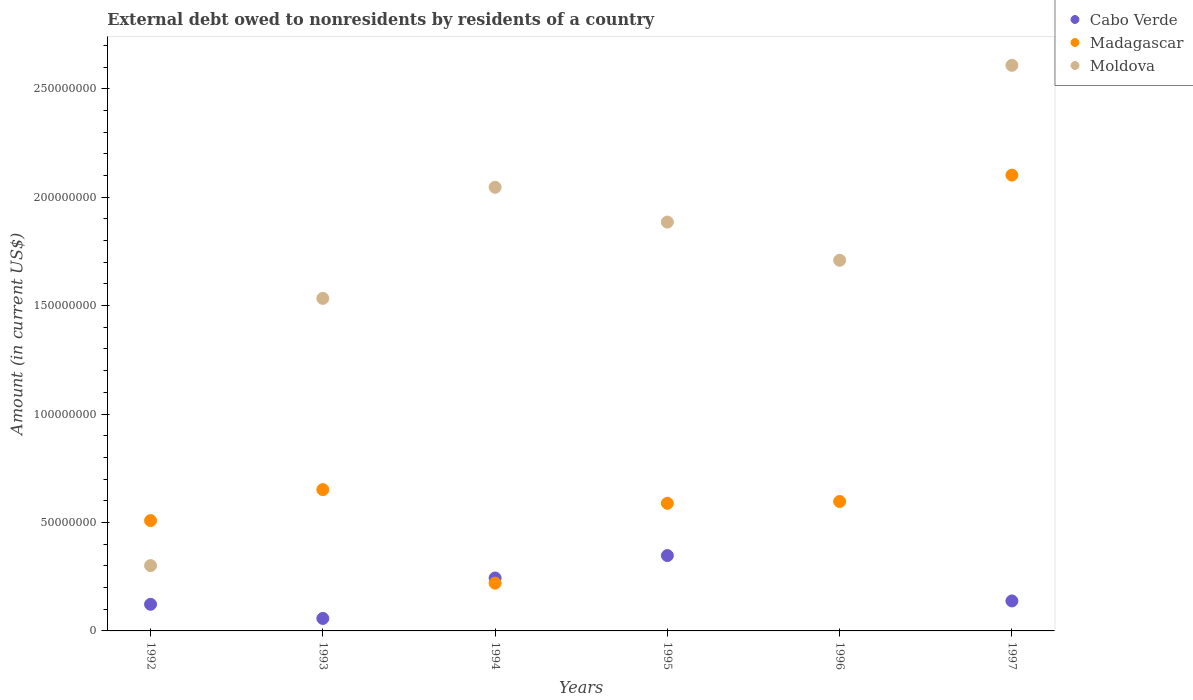How many different coloured dotlines are there?
Offer a terse response. 3. Is the number of dotlines equal to the number of legend labels?
Offer a terse response. No. What is the external debt owed by residents in Moldova in 1994?
Offer a terse response. 2.05e+08. Across all years, what is the maximum external debt owed by residents in Cabo Verde?
Your answer should be very brief. 3.47e+07. Across all years, what is the minimum external debt owed by residents in Madagascar?
Make the answer very short. 2.20e+07. In which year was the external debt owed by residents in Moldova maximum?
Your response must be concise. 1997. What is the total external debt owed by residents in Madagascar in the graph?
Make the answer very short. 4.67e+08. What is the difference between the external debt owed by residents in Madagascar in 1994 and that in 1997?
Ensure brevity in your answer.  -1.88e+08. What is the difference between the external debt owed by residents in Cabo Verde in 1992 and the external debt owed by residents in Madagascar in 1995?
Keep it short and to the point. -4.66e+07. What is the average external debt owed by residents in Madagascar per year?
Keep it short and to the point. 7.78e+07. In the year 1993, what is the difference between the external debt owed by residents in Moldova and external debt owed by residents in Madagascar?
Provide a short and direct response. 8.82e+07. What is the ratio of the external debt owed by residents in Moldova in 1994 to that in 1996?
Your answer should be very brief. 1.2. Is the difference between the external debt owed by residents in Moldova in 1993 and 1994 greater than the difference between the external debt owed by residents in Madagascar in 1993 and 1994?
Give a very brief answer. No. What is the difference between the highest and the second highest external debt owed by residents in Madagascar?
Make the answer very short. 1.45e+08. What is the difference between the highest and the lowest external debt owed by residents in Madagascar?
Your answer should be compact. 1.88e+08. In how many years, is the external debt owed by residents in Madagascar greater than the average external debt owed by residents in Madagascar taken over all years?
Ensure brevity in your answer.  1. Is the sum of the external debt owed by residents in Moldova in 1993 and 1995 greater than the maximum external debt owed by residents in Madagascar across all years?
Keep it short and to the point. Yes. Is it the case that in every year, the sum of the external debt owed by residents in Moldova and external debt owed by residents in Madagascar  is greater than the external debt owed by residents in Cabo Verde?
Keep it short and to the point. Yes. Does the external debt owed by residents in Moldova monotonically increase over the years?
Provide a succinct answer. No. How many dotlines are there?
Ensure brevity in your answer.  3. How many years are there in the graph?
Your response must be concise. 6. What is the difference between two consecutive major ticks on the Y-axis?
Offer a terse response. 5.00e+07. Does the graph contain grids?
Ensure brevity in your answer.  No. How are the legend labels stacked?
Make the answer very short. Vertical. What is the title of the graph?
Make the answer very short. External debt owed to nonresidents by residents of a country. Does "St. Lucia" appear as one of the legend labels in the graph?
Make the answer very short. No. What is the label or title of the Y-axis?
Keep it short and to the point. Amount (in current US$). What is the Amount (in current US$) of Cabo Verde in 1992?
Make the answer very short. 1.23e+07. What is the Amount (in current US$) of Madagascar in 1992?
Provide a short and direct response. 5.09e+07. What is the Amount (in current US$) of Moldova in 1992?
Make the answer very short. 3.01e+07. What is the Amount (in current US$) in Cabo Verde in 1993?
Your answer should be compact. 5.76e+06. What is the Amount (in current US$) of Madagascar in 1993?
Give a very brief answer. 6.52e+07. What is the Amount (in current US$) of Moldova in 1993?
Offer a very short reply. 1.53e+08. What is the Amount (in current US$) in Cabo Verde in 1994?
Offer a terse response. 2.44e+07. What is the Amount (in current US$) in Madagascar in 1994?
Provide a short and direct response. 2.20e+07. What is the Amount (in current US$) in Moldova in 1994?
Provide a short and direct response. 2.05e+08. What is the Amount (in current US$) in Cabo Verde in 1995?
Give a very brief answer. 3.47e+07. What is the Amount (in current US$) in Madagascar in 1995?
Provide a short and direct response. 5.88e+07. What is the Amount (in current US$) in Moldova in 1995?
Keep it short and to the point. 1.89e+08. What is the Amount (in current US$) of Cabo Verde in 1996?
Keep it short and to the point. 0. What is the Amount (in current US$) in Madagascar in 1996?
Keep it short and to the point. 5.97e+07. What is the Amount (in current US$) in Moldova in 1996?
Offer a very short reply. 1.71e+08. What is the Amount (in current US$) in Cabo Verde in 1997?
Your answer should be very brief. 1.38e+07. What is the Amount (in current US$) in Madagascar in 1997?
Offer a terse response. 2.10e+08. What is the Amount (in current US$) in Moldova in 1997?
Ensure brevity in your answer.  2.61e+08. Across all years, what is the maximum Amount (in current US$) of Cabo Verde?
Offer a very short reply. 3.47e+07. Across all years, what is the maximum Amount (in current US$) in Madagascar?
Your answer should be very brief. 2.10e+08. Across all years, what is the maximum Amount (in current US$) of Moldova?
Keep it short and to the point. 2.61e+08. Across all years, what is the minimum Amount (in current US$) in Madagascar?
Give a very brief answer. 2.20e+07. Across all years, what is the minimum Amount (in current US$) in Moldova?
Ensure brevity in your answer.  3.01e+07. What is the total Amount (in current US$) of Cabo Verde in the graph?
Make the answer very short. 9.10e+07. What is the total Amount (in current US$) of Madagascar in the graph?
Provide a short and direct response. 4.67e+08. What is the total Amount (in current US$) in Moldova in the graph?
Ensure brevity in your answer.  1.01e+09. What is the difference between the Amount (in current US$) in Cabo Verde in 1992 and that in 1993?
Make the answer very short. 6.51e+06. What is the difference between the Amount (in current US$) in Madagascar in 1992 and that in 1993?
Make the answer very short. -1.43e+07. What is the difference between the Amount (in current US$) of Moldova in 1992 and that in 1993?
Provide a succinct answer. -1.23e+08. What is the difference between the Amount (in current US$) in Cabo Verde in 1992 and that in 1994?
Make the answer very short. -1.21e+07. What is the difference between the Amount (in current US$) of Madagascar in 1992 and that in 1994?
Ensure brevity in your answer.  2.89e+07. What is the difference between the Amount (in current US$) in Moldova in 1992 and that in 1994?
Your answer should be compact. -1.74e+08. What is the difference between the Amount (in current US$) in Cabo Verde in 1992 and that in 1995?
Your answer should be compact. -2.25e+07. What is the difference between the Amount (in current US$) in Madagascar in 1992 and that in 1995?
Offer a terse response. -7.97e+06. What is the difference between the Amount (in current US$) of Moldova in 1992 and that in 1995?
Your response must be concise. -1.58e+08. What is the difference between the Amount (in current US$) in Madagascar in 1992 and that in 1996?
Give a very brief answer. -8.81e+06. What is the difference between the Amount (in current US$) in Moldova in 1992 and that in 1996?
Give a very brief answer. -1.41e+08. What is the difference between the Amount (in current US$) in Cabo Verde in 1992 and that in 1997?
Provide a short and direct response. -1.55e+06. What is the difference between the Amount (in current US$) in Madagascar in 1992 and that in 1997?
Offer a terse response. -1.59e+08. What is the difference between the Amount (in current US$) of Moldova in 1992 and that in 1997?
Make the answer very short. -2.31e+08. What is the difference between the Amount (in current US$) in Cabo Verde in 1993 and that in 1994?
Provide a succinct answer. -1.86e+07. What is the difference between the Amount (in current US$) in Madagascar in 1993 and that in 1994?
Offer a very short reply. 4.31e+07. What is the difference between the Amount (in current US$) of Moldova in 1993 and that in 1994?
Give a very brief answer. -5.12e+07. What is the difference between the Amount (in current US$) of Cabo Verde in 1993 and that in 1995?
Make the answer very short. -2.90e+07. What is the difference between the Amount (in current US$) in Madagascar in 1993 and that in 1995?
Ensure brevity in your answer.  6.31e+06. What is the difference between the Amount (in current US$) of Moldova in 1993 and that in 1995?
Your response must be concise. -3.52e+07. What is the difference between the Amount (in current US$) in Madagascar in 1993 and that in 1996?
Your answer should be compact. 5.46e+06. What is the difference between the Amount (in current US$) in Moldova in 1993 and that in 1996?
Offer a very short reply. -1.76e+07. What is the difference between the Amount (in current US$) in Cabo Verde in 1993 and that in 1997?
Provide a succinct answer. -8.06e+06. What is the difference between the Amount (in current US$) of Madagascar in 1993 and that in 1997?
Keep it short and to the point. -1.45e+08. What is the difference between the Amount (in current US$) of Moldova in 1993 and that in 1997?
Provide a short and direct response. -1.07e+08. What is the difference between the Amount (in current US$) of Cabo Verde in 1994 and that in 1995?
Offer a terse response. -1.03e+07. What is the difference between the Amount (in current US$) in Madagascar in 1994 and that in 1995?
Your answer should be very brief. -3.68e+07. What is the difference between the Amount (in current US$) of Moldova in 1994 and that in 1995?
Make the answer very short. 1.60e+07. What is the difference between the Amount (in current US$) in Madagascar in 1994 and that in 1996?
Offer a terse response. -3.77e+07. What is the difference between the Amount (in current US$) of Moldova in 1994 and that in 1996?
Provide a succinct answer. 3.37e+07. What is the difference between the Amount (in current US$) of Cabo Verde in 1994 and that in 1997?
Ensure brevity in your answer.  1.06e+07. What is the difference between the Amount (in current US$) of Madagascar in 1994 and that in 1997?
Make the answer very short. -1.88e+08. What is the difference between the Amount (in current US$) of Moldova in 1994 and that in 1997?
Keep it short and to the point. -5.62e+07. What is the difference between the Amount (in current US$) in Madagascar in 1995 and that in 1996?
Give a very brief answer. -8.45e+05. What is the difference between the Amount (in current US$) in Moldova in 1995 and that in 1996?
Provide a short and direct response. 1.76e+07. What is the difference between the Amount (in current US$) in Cabo Verde in 1995 and that in 1997?
Ensure brevity in your answer.  2.09e+07. What is the difference between the Amount (in current US$) in Madagascar in 1995 and that in 1997?
Offer a terse response. -1.51e+08. What is the difference between the Amount (in current US$) in Moldova in 1995 and that in 1997?
Give a very brief answer. -7.23e+07. What is the difference between the Amount (in current US$) of Madagascar in 1996 and that in 1997?
Your response must be concise. -1.50e+08. What is the difference between the Amount (in current US$) of Moldova in 1996 and that in 1997?
Make the answer very short. -8.99e+07. What is the difference between the Amount (in current US$) of Cabo Verde in 1992 and the Amount (in current US$) of Madagascar in 1993?
Your answer should be compact. -5.29e+07. What is the difference between the Amount (in current US$) in Cabo Verde in 1992 and the Amount (in current US$) in Moldova in 1993?
Provide a short and direct response. -1.41e+08. What is the difference between the Amount (in current US$) of Madagascar in 1992 and the Amount (in current US$) of Moldova in 1993?
Your answer should be very brief. -1.02e+08. What is the difference between the Amount (in current US$) of Cabo Verde in 1992 and the Amount (in current US$) of Madagascar in 1994?
Provide a short and direct response. -9.75e+06. What is the difference between the Amount (in current US$) of Cabo Verde in 1992 and the Amount (in current US$) of Moldova in 1994?
Ensure brevity in your answer.  -1.92e+08. What is the difference between the Amount (in current US$) in Madagascar in 1992 and the Amount (in current US$) in Moldova in 1994?
Provide a succinct answer. -1.54e+08. What is the difference between the Amount (in current US$) of Cabo Verde in 1992 and the Amount (in current US$) of Madagascar in 1995?
Ensure brevity in your answer.  -4.66e+07. What is the difference between the Amount (in current US$) of Cabo Verde in 1992 and the Amount (in current US$) of Moldova in 1995?
Your answer should be compact. -1.76e+08. What is the difference between the Amount (in current US$) of Madagascar in 1992 and the Amount (in current US$) of Moldova in 1995?
Make the answer very short. -1.38e+08. What is the difference between the Amount (in current US$) in Cabo Verde in 1992 and the Amount (in current US$) in Madagascar in 1996?
Offer a terse response. -4.74e+07. What is the difference between the Amount (in current US$) in Cabo Verde in 1992 and the Amount (in current US$) in Moldova in 1996?
Your answer should be compact. -1.59e+08. What is the difference between the Amount (in current US$) of Madagascar in 1992 and the Amount (in current US$) of Moldova in 1996?
Ensure brevity in your answer.  -1.20e+08. What is the difference between the Amount (in current US$) in Cabo Verde in 1992 and the Amount (in current US$) in Madagascar in 1997?
Offer a very short reply. -1.98e+08. What is the difference between the Amount (in current US$) of Cabo Verde in 1992 and the Amount (in current US$) of Moldova in 1997?
Provide a short and direct response. -2.49e+08. What is the difference between the Amount (in current US$) in Madagascar in 1992 and the Amount (in current US$) in Moldova in 1997?
Your answer should be compact. -2.10e+08. What is the difference between the Amount (in current US$) in Cabo Verde in 1993 and the Amount (in current US$) in Madagascar in 1994?
Your answer should be compact. -1.63e+07. What is the difference between the Amount (in current US$) in Cabo Verde in 1993 and the Amount (in current US$) in Moldova in 1994?
Offer a very short reply. -1.99e+08. What is the difference between the Amount (in current US$) in Madagascar in 1993 and the Amount (in current US$) in Moldova in 1994?
Give a very brief answer. -1.39e+08. What is the difference between the Amount (in current US$) of Cabo Verde in 1993 and the Amount (in current US$) of Madagascar in 1995?
Your answer should be very brief. -5.31e+07. What is the difference between the Amount (in current US$) of Cabo Verde in 1993 and the Amount (in current US$) of Moldova in 1995?
Offer a very short reply. -1.83e+08. What is the difference between the Amount (in current US$) in Madagascar in 1993 and the Amount (in current US$) in Moldova in 1995?
Provide a short and direct response. -1.23e+08. What is the difference between the Amount (in current US$) of Cabo Verde in 1993 and the Amount (in current US$) of Madagascar in 1996?
Your answer should be compact. -5.39e+07. What is the difference between the Amount (in current US$) in Cabo Verde in 1993 and the Amount (in current US$) in Moldova in 1996?
Offer a very short reply. -1.65e+08. What is the difference between the Amount (in current US$) of Madagascar in 1993 and the Amount (in current US$) of Moldova in 1996?
Ensure brevity in your answer.  -1.06e+08. What is the difference between the Amount (in current US$) of Cabo Verde in 1993 and the Amount (in current US$) of Madagascar in 1997?
Offer a very short reply. -2.04e+08. What is the difference between the Amount (in current US$) of Cabo Verde in 1993 and the Amount (in current US$) of Moldova in 1997?
Make the answer very short. -2.55e+08. What is the difference between the Amount (in current US$) of Madagascar in 1993 and the Amount (in current US$) of Moldova in 1997?
Make the answer very short. -1.96e+08. What is the difference between the Amount (in current US$) of Cabo Verde in 1994 and the Amount (in current US$) of Madagascar in 1995?
Your response must be concise. -3.44e+07. What is the difference between the Amount (in current US$) in Cabo Verde in 1994 and the Amount (in current US$) in Moldova in 1995?
Offer a very short reply. -1.64e+08. What is the difference between the Amount (in current US$) in Madagascar in 1994 and the Amount (in current US$) in Moldova in 1995?
Make the answer very short. -1.66e+08. What is the difference between the Amount (in current US$) of Cabo Verde in 1994 and the Amount (in current US$) of Madagascar in 1996?
Make the answer very short. -3.53e+07. What is the difference between the Amount (in current US$) in Cabo Verde in 1994 and the Amount (in current US$) in Moldova in 1996?
Your answer should be compact. -1.46e+08. What is the difference between the Amount (in current US$) in Madagascar in 1994 and the Amount (in current US$) in Moldova in 1996?
Keep it short and to the point. -1.49e+08. What is the difference between the Amount (in current US$) in Cabo Verde in 1994 and the Amount (in current US$) in Madagascar in 1997?
Keep it short and to the point. -1.86e+08. What is the difference between the Amount (in current US$) in Cabo Verde in 1994 and the Amount (in current US$) in Moldova in 1997?
Provide a short and direct response. -2.36e+08. What is the difference between the Amount (in current US$) in Madagascar in 1994 and the Amount (in current US$) in Moldova in 1997?
Your answer should be compact. -2.39e+08. What is the difference between the Amount (in current US$) in Cabo Verde in 1995 and the Amount (in current US$) in Madagascar in 1996?
Your answer should be compact. -2.49e+07. What is the difference between the Amount (in current US$) in Cabo Verde in 1995 and the Amount (in current US$) in Moldova in 1996?
Ensure brevity in your answer.  -1.36e+08. What is the difference between the Amount (in current US$) in Madagascar in 1995 and the Amount (in current US$) in Moldova in 1996?
Give a very brief answer. -1.12e+08. What is the difference between the Amount (in current US$) in Cabo Verde in 1995 and the Amount (in current US$) in Madagascar in 1997?
Ensure brevity in your answer.  -1.75e+08. What is the difference between the Amount (in current US$) in Cabo Verde in 1995 and the Amount (in current US$) in Moldova in 1997?
Keep it short and to the point. -2.26e+08. What is the difference between the Amount (in current US$) of Madagascar in 1995 and the Amount (in current US$) of Moldova in 1997?
Give a very brief answer. -2.02e+08. What is the difference between the Amount (in current US$) in Madagascar in 1996 and the Amount (in current US$) in Moldova in 1997?
Your response must be concise. -2.01e+08. What is the average Amount (in current US$) in Cabo Verde per year?
Give a very brief answer. 1.52e+07. What is the average Amount (in current US$) of Madagascar per year?
Your answer should be compact. 7.78e+07. What is the average Amount (in current US$) of Moldova per year?
Keep it short and to the point. 1.68e+08. In the year 1992, what is the difference between the Amount (in current US$) of Cabo Verde and Amount (in current US$) of Madagascar?
Keep it short and to the point. -3.86e+07. In the year 1992, what is the difference between the Amount (in current US$) in Cabo Verde and Amount (in current US$) in Moldova?
Make the answer very short. -1.79e+07. In the year 1992, what is the difference between the Amount (in current US$) of Madagascar and Amount (in current US$) of Moldova?
Give a very brief answer. 2.07e+07. In the year 1993, what is the difference between the Amount (in current US$) of Cabo Verde and Amount (in current US$) of Madagascar?
Provide a short and direct response. -5.94e+07. In the year 1993, what is the difference between the Amount (in current US$) in Cabo Verde and Amount (in current US$) in Moldova?
Offer a very short reply. -1.48e+08. In the year 1993, what is the difference between the Amount (in current US$) in Madagascar and Amount (in current US$) in Moldova?
Offer a very short reply. -8.82e+07. In the year 1994, what is the difference between the Amount (in current US$) of Cabo Verde and Amount (in current US$) of Madagascar?
Ensure brevity in your answer.  2.39e+06. In the year 1994, what is the difference between the Amount (in current US$) in Cabo Verde and Amount (in current US$) in Moldova?
Offer a very short reply. -1.80e+08. In the year 1994, what is the difference between the Amount (in current US$) in Madagascar and Amount (in current US$) in Moldova?
Offer a terse response. -1.83e+08. In the year 1995, what is the difference between the Amount (in current US$) of Cabo Verde and Amount (in current US$) of Madagascar?
Your response must be concise. -2.41e+07. In the year 1995, what is the difference between the Amount (in current US$) of Cabo Verde and Amount (in current US$) of Moldova?
Give a very brief answer. -1.54e+08. In the year 1995, what is the difference between the Amount (in current US$) of Madagascar and Amount (in current US$) of Moldova?
Offer a terse response. -1.30e+08. In the year 1996, what is the difference between the Amount (in current US$) of Madagascar and Amount (in current US$) of Moldova?
Provide a short and direct response. -1.11e+08. In the year 1997, what is the difference between the Amount (in current US$) in Cabo Verde and Amount (in current US$) in Madagascar?
Provide a short and direct response. -1.96e+08. In the year 1997, what is the difference between the Amount (in current US$) in Cabo Verde and Amount (in current US$) in Moldova?
Make the answer very short. -2.47e+08. In the year 1997, what is the difference between the Amount (in current US$) in Madagascar and Amount (in current US$) in Moldova?
Give a very brief answer. -5.06e+07. What is the ratio of the Amount (in current US$) of Cabo Verde in 1992 to that in 1993?
Your answer should be compact. 2.13. What is the ratio of the Amount (in current US$) in Madagascar in 1992 to that in 1993?
Offer a terse response. 0.78. What is the ratio of the Amount (in current US$) in Moldova in 1992 to that in 1993?
Make the answer very short. 0.2. What is the ratio of the Amount (in current US$) of Cabo Verde in 1992 to that in 1994?
Give a very brief answer. 0.5. What is the ratio of the Amount (in current US$) in Madagascar in 1992 to that in 1994?
Provide a short and direct response. 2.31. What is the ratio of the Amount (in current US$) in Moldova in 1992 to that in 1994?
Your answer should be very brief. 0.15. What is the ratio of the Amount (in current US$) of Cabo Verde in 1992 to that in 1995?
Ensure brevity in your answer.  0.35. What is the ratio of the Amount (in current US$) in Madagascar in 1992 to that in 1995?
Offer a very short reply. 0.86. What is the ratio of the Amount (in current US$) in Moldova in 1992 to that in 1995?
Make the answer very short. 0.16. What is the ratio of the Amount (in current US$) in Madagascar in 1992 to that in 1996?
Offer a very short reply. 0.85. What is the ratio of the Amount (in current US$) of Moldova in 1992 to that in 1996?
Your response must be concise. 0.18. What is the ratio of the Amount (in current US$) in Cabo Verde in 1992 to that in 1997?
Give a very brief answer. 0.89. What is the ratio of the Amount (in current US$) of Madagascar in 1992 to that in 1997?
Your response must be concise. 0.24. What is the ratio of the Amount (in current US$) of Moldova in 1992 to that in 1997?
Make the answer very short. 0.12. What is the ratio of the Amount (in current US$) in Cabo Verde in 1993 to that in 1994?
Your response must be concise. 0.24. What is the ratio of the Amount (in current US$) of Madagascar in 1993 to that in 1994?
Provide a succinct answer. 2.96. What is the ratio of the Amount (in current US$) in Moldova in 1993 to that in 1994?
Keep it short and to the point. 0.75. What is the ratio of the Amount (in current US$) in Cabo Verde in 1993 to that in 1995?
Offer a very short reply. 0.17. What is the ratio of the Amount (in current US$) in Madagascar in 1993 to that in 1995?
Give a very brief answer. 1.11. What is the ratio of the Amount (in current US$) in Moldova in 1993 to that in 1995?
Your response must be concise. 0.81. What is the ratio of the Amount (in current US$) in Madagascar in 1993 to that in 1996?
Provide a short and direct response. 1.09. What is the ratio of the Amount (in current US$) in Moldova in 1993 to that in 1996?
Your response must be concise. 0.9. What is the ratio of the Amount (in current US$) in Cabo Verde in 1993 to that in 1997?
Give a very brief answer. 0.42. What is the ratio of the Amount (in current US$) in Madagascar in 1993 to that in 1997?
Ensure brevity in your answer.  0.31. What is the ratio of the Amount (in current US$) in Moldova in 1993 to that in 1997?
Make the answer very short. 0.59. What is the ratio of the Amount (in current US$) of Cabo Verde in 1994 to that in 1995?
Keep it short and to the point. 0.7. What is the ratio of the Amount (in current US$) of Madagascar in 1994 to that in 1995?
Give a very brief answer. 0.37. What is the ratio of the Amount (in current US$) of Moldova in 1994 to that in 1995?
Make the answer very short. 1.09. What is the ratio of the Amount (in current US$) in Madagascar in 1994 to that in 1996?
Offer a terse response. 0.37. What is the ratio of the Amount (in current US$) of Moldova in 1994 to that in 1996?
Give a very brief answer. 1.2. What is the ratio of the Amount (in current US$) in Cabo Verde in 1994 to that in 1997?
Your answer should be very brief. 1.77. What is the ratio of the Amount (in current US$) in Madagascar in 1994 to that in 1997?
Offer a very short reply. 0.1. What is the ratio of the Amount (in current US$) of Moldova in 1994 to that in 1997?
Offer a terse response. 0.78. What is the ratio of the Amount (in current US$) in Madagascar in 1995 to that in 1996?
Give a very brief answer. 0.99. What is the ratio of the Amount (in current US$) in Moldova in 1995 to that in 1996?
Keep it short and to the point. 1.1. What is the ratio of the Amount (in current US$) in Cabo Verde in 1995 to that in 1997?
Provide a succinct answer. 2.51. What is the ratio of the Amount (in current US$) in Madagascar in 1995 to that in 1997?
Offer a terse response. 0.28. What is the ratio of the Amount (in current US$) of Moldova in 1995 to that in 1997?
Provide a short and direct response. 0.72. What is the ratio of the Amount (in current US$) in Madagascar in 1996 to that in 1997?
Keep it short and to the point. 0.28. What is the ratio of the Amount (in current US$) in Moldova in 1996 to that in 1997?
Your response must be concise. 0.66. What is the difference between the highest and the second highest Amount (in current US$) of Cabo Verde?
Make the answer very short. 1.03e+07. What is the difference between the highest and the second highest Amount (in current US$) in Madagascar?
Offer a very short reply. 1.45e+08. What is the difference between the highest and the second highest Amount (in current US$) in Moldova?
Make the answer very short. 5.62e+07. What is the difference between the highest and the lowest Amount (in current US$) of Cabo Verde?
Your answer should be very brief. 3.47e+07. What is the difference between the highest and the lowest Amount (in current US$) of Madagascar?
Make the answer very short. 1.88e+08. What is the difference between the highest and the lowest Amount (in current US$) of Moldova?
Your answer should be very brief. 2.31e+08. 